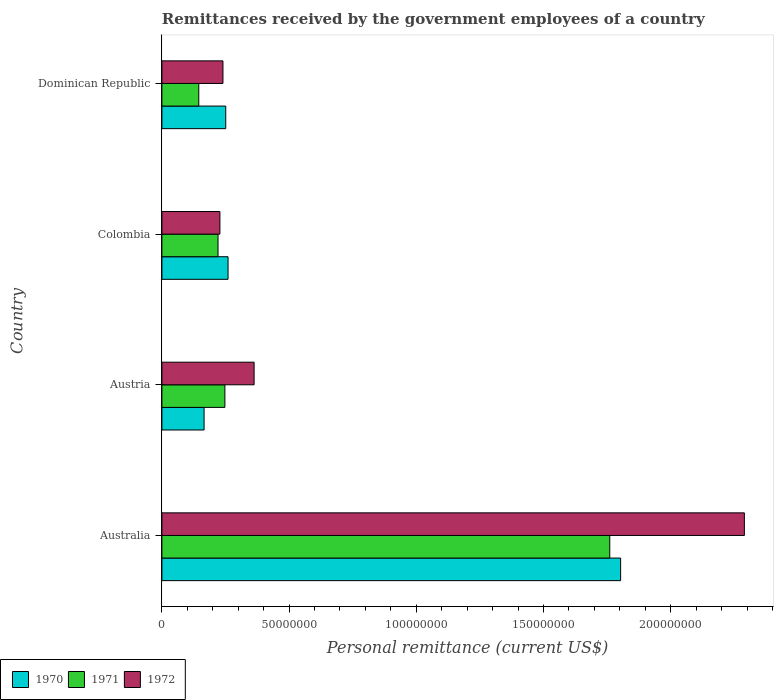How many different coloured bars are there?
Your answer should be compact. 3. How many bars are there on the 3rd tick from the top?
Offer a very short reply. 3. How many bars are there on the 4th tick from the bottom?
Ensure brevity in your answer.  3. What is the label of the 3rd group of bars from the top?
Your response must be concise. Austria. In how many cases, is the number of bars for a given country not equal to the number of legend labels?
Keep it short and to the point. 0. What is the remittances received by the government employees in 1972 in Colombia?
Keep it short and to the point. 2.28e+07. Across all countries, what is the maximum remittances received by the government employees in 1971?
Keep it short and to the point. 1.76e+08. Across all countries, what is the minimum remittances received by the government employees in 1970?
Keep it short and to the point. 1.66e+07. In which country was the remittances received by the government employees in 1971 maximum?
Your answer should be compact. Australia. What is the total remittances received by the government employees in 1972 in the graph?
Give a very brief answer. 3.12e+08. What is the difference between the remittances received by the government employees in 1971 in Colombia and that in Dominican Republic?
Keep it short and to the point. 7.57e+06. What is the difference between the remittances received by the government employees in 1970 in Austria and the remittances received by the government employees in 1971 in Australia?
Offer a terse response. -1.59e+08. What is the average remittances received by the government employees in 1972 per country?
Your response must be concise. 7.80e+07. What is the difference between the remittances received by the government employees in 1972 and remittances received by the government employees in 1970 in Austria?
Ensure brevity in your answer.  1.97e+07. What is the ratio of the remittances received by the government employees in 1972 in Austria to that in Dominican Republic?
Your answer should be compact. 1.51. Is the remittances received by the government employees in 1972 in Austria less than that in Dominican Republic?
Keep it short and to the point. No. Is the difference between the remittances received by the government employees in 1972 in Australia and Colombia greater than the difference between the remittances received by the government employees in 1970 in Australia and Colombia?
Keep it short and to the point. Yes. What is the difference between the highest and the second highest remittances received by the government employees in 1971?
Ensure brevity in your answer.  1.51e+08. What is the difference between the highest and the lowest remittances received by the government employees in 1970?
Give a very brief answer. 1.64e+08. What does the 3rd bar from the bottom in Austria represents?
Provide a succinct answer. 1972. How many bars are there?
Your answer should be very brief. 12. Are all the bars in the graph horizontal?
Your answer should be very brief. Yes. What is the difference between two consecutive major ticks on the X-axis?
Your response must be concise. 5.00e+07. Does the graph contain any zero values?
Give a very brief answer. No. Does the graph contain grids?
Your answer should be very brief. No. How are the legend labels stacked?
Make the answer very short. Horizontal. What is the title of the graph?
Make the answer very short. Remittances received by the government employees of a country. What is the label or title of the X-axis?
Provide a succinct answer. Personal remittance (current US$). What is the label or title of the Y-axis?
Give a very brief answer. Country. What is the Personal remittance (current US$) of 1970 in Australia?
Give a very brief answer. 1.80e+08. What is the Personal remittance (current US$) in 1971 in Australia?
Keep it short and to the point. 1.76e+08. What is the Personal remittance (current US$) in 1972 in Australia?
Provide a succinct answer. 2.29e+08. What is the Personal remittance (current US$) of 1970 in Austria?
Ensure brevity in your answer.  1.66e+07. What is the Personal remittance (current US$) of 1971 in Austria?
Give a very brief answer. 2.48e+07. What is the Personal remittance (current US$) in 1972 in Austria?
Ensure brevity in your answer.  3.62e+07. What is the Personal remittance (current US$) of 1970 in Colombia?
Make the answer very short. 2.60e+07. What is the Personal remittance (current US$) in 1971 in Colombia?
Provide a short and direct response. 2.21e+07. What is the Personal remittance (current US$) of 1972 in Colombia?
Your answer should be compact. 2.28e+07. What is the Personal remittance (current US$) of 1970 in Dominican Republic?
Ensure brevity in your answer.  2.51e+07. What is the Personal remittance (current US$) in 1971 in Dominican Republic?
Offer a terse response. 1.45e+07. What is the Personal remittance (current US$) of 1972 in Dominican Republic?
Keep it short and to the point. 2.40e+07. Across all countries, what is the maximum Personal remittance (current US$) in 1970?
Provide a succinct answer. 1.80e+08. Across all countries, what is the maximum Personal remittance (current US$) in 1971?
Keep it short and to the point. 1.76e+08. Across all countries, what is the maximum Personal remittance (current US$) of 1972?
Offer a terse response. 2.29e+08. Across all countries, what is the minimum Personal remittance (current US$) of 1970?
Make the answer very short. 1.66e+07. Across all countries, what is the minimum Personal remittance (current US$) of 1971?
Provide a short and direct response. 1.45e+07. Across all countries, what is the minimum Personal remittance (current US$) of 1972?
Offer a very short reply. 2.28e+07. What is the total Personal remittance (current US$) of 1970 in the graph?
Your response must be concise. 2.48e+08. What is the total Personal remittance (current US$) in 1971 in the graph?
Your response must be concise. 2.37e+08. What is the total Personal remittance (current US$) in 1972 in the graph?
Your answer should be very brief. 3.12e+08. What is the difference between the Personal remittance (current US$) of 1970 in Australia and that in Austria?
Give a very brief answer. 1.64e+08. What is the difference between the Personal remittance (current US$) in 1971 in Australia and that in Austria?
Your response must be concise. 1.51e+08. What is the difference between the Personal remittance (current US$) in 1972 in Australia and that in Austria?
Offer a very short reply. 1.93e+08. What is the difference between the Personal remittance (current US$) in 1970 in Australia and that in Colombia?
Your answer should be very brief. 1.54e+08. What is the difference between the Personal remittance (current US$) of 1971 in Australia and that in Colombia?
Make the answer very short. 1.54e+08. What is the difference between the Personal remittance (current US$) in 1972 in Australia and that in Colombia?
Offer a terse response. 2.06e+08. What is the difference between the Personal remittance (current US$) of 1970 in Australia and that in Dominican Republic?
Offer a very short reply. 1.55e+08. What is the difference between the Personal remittance (current US$) in 1971 in Australia and that in Dominican Republic?
Your answer should be compact. 1.62e+08. What is the difference between the Personal remittance (current US$) in 1972 in Australia and that in Dominican Republic?
Provide a short and direct response. 2.05e+08. What is the difference between the Personal remittance (current US$) in 1970 in Austria and that in Colombia?
Make the answer very short. -9.42e+06. What is the difference between the Personal remittance (current US$) of 1971 in Austria and that in Colombia?
Your answer should be compact. 2.69e+06. What is the difference between the Personal remittance (current US$) in 1972 in Austria and that in Colombia?
Offer a terse response. 1.34e+07. What is the difference between the Personal remittance (current US$) in 1970 in Austria and that in Dominican Republic?
Your answer should be very brief. -8.52e+06. What is the difference between the Personal remittance (current US$) in 1971 in Austria and that in Dominican Republic?
Provide a succinct answer. 1.03e+07. What is the difference between the Personal remittance (current US$) in 1972 in Austria and that in Dominican Republic?
Give a very brief answer. 1.22e+07. What is the difference between the Personal remittance (current US$) of 1970 in Colombia and that in Dominican Republic?
Keep it short and to the point. 9.00e+05. What is the difference between the Personal remittance (current US$) of 1971 in Colombia and that in Dominican Republic?
Provide a short and direct response. 7.57e+06. What is the difference between the Personal remittance (current US$) in 1972 in Colombia and that in Dominican Republic?
Provide a succinct answer. -1.20e+06. What is the difference between the Personal remittance (current US$) of 1970 in Australia and the Personal remittance (current US$) of 1971 in Austria?
Give a very brief answer. 1.56e+08. What is the difference between the Personal remittance (current US$) of 1970 in Australia and the Personal remittance (current US$) of 1972 in Austria?
Your response must be concise. 1.44e+08. What is the difference between the Personal remittance (current US$) in 1971 in Australia and the Personal remittance (current US$) in 1972 in Austria?
Provide a succinct answer. 1.40e+08. What is the difference between the Personal remittance (current US$) of 1970 in Australia and the Personal remittance (current US$) of 1971 in Colombia?
Your response must be concise. 1.58e+08. What is the difference between the Personal remittance (current US$) of 1970 in Australia and the Personal remittance (current US$) of 1972 in Colombia?
Make the answer very short. 1.58e+08. What is the difference between the Personal remittance (current US$) in 1971 in Australia and the Personal remittance (current US$) in 1972 in Colombia?
Give a very brief answer. 1.53e+08. What is the difference between the Personal remittance (current US$) in 1970 in Australia and the Personal remittance (current US$) in 1971 in Dominican Republic?
Make the answer very short. 1.66e+08. What is the difference between the Personal remittance (current US$) in 1970 in Australia and the Personal remittance (current US$) in 1972 in Dominican Republic?
Your response must be concise. 1.56e+08. What is the difference between the Personal remittance (current US$) in 1971 in Australia and the Personal remittance (current US$) in 1972 in Dominican Republic?
Provide a short and direct response. 1.52e+08. What is the difference between the Personal remittance (current US$) of 1970 in Austria and the Personal remittance (current US$) of 1971 in Colombia?
Your response must be concise. -5.49e+06. What is the difference between the Personal remittance (current US$) in 1970 in Austria and the Personal remittance (current US$) in 1972 in Colombia?
Make the answer very short. -6.22e+06. What is the difference between the Personal remittance (current US$) in 1971 in Austria and the Personal remittance (current US$) in 1972 in Colombia?
Your response must be concise. 1.96e+06. What is the difference between the Personal remittance (current US$) in 1970 in Austria and the Personal remittance (current US$) in 1971 in Dominican Republic?
Offer a terse response. 2.08e+06. What is the difference between the Personal remittance (current US$) in 1970 in Austria and the Personal remittance (current US$) in 1972 in Dominican Republic?
Provide a short and direct response. -7.42e+06. What is the difference between the Personal remittance (current US$) in 1971 in Austria and the Personal remittance (current US$) in 1972 in Dominican Republic?
Give a very brief answer. 7.60e+05. What is the difference between the Personal remittance (current US$) in 1970 in Colombia and the Personal remittance (current US$) in 1971 in Dominican Republic?
Give a very brief answer. 1.15e+07. What is the difference between the Personal remittance (current US$) of 1971 in Colombia and the Personal remittance (current US$) of 1972 in Dominican Republic?
Keep it short and to the point. -1.93e+06. What is the average Personal remittance (current US$) in 1970 per country?
Make the answer very short. 6.20e+07. What is the average Personal remittance (current US$) in 1971 per country?
Provide a succinct answer. 5.93e+07. What is the average Personal remittance (current US$) of 1972 per country?
Offer a terse response. 7.80e+07. What is the difference between the Personal remittance (current US$) in 1970 and Personal remittance (current US$) in 1971 in Australia?
Provide a short and direct response. 4.27e+06. What is the difference between the Personal remittance (current US$) of 1970 and Personal remittance (current US$) of 1972 in Australia?
Offer a very short reply. -4.86e+07. What is the difference between the Personal remittance (current US$) in 1971 and Personal remittance (current US$) in 1972 in Australia?
Your answer should be very brief. -5.29e+07. What is the difference between the Personal remittance (current US$) in 1970 and Personal remittance (current US$) in 1971 in Austria?
Ensure brevity in your answer.  -8.18e+06. What is the difference between the Personal remittance (current US$) of 1970 and Personal remittance (current US$) of 1972 in Austria?
Keep it short and to the point. -1.97e+07. What is the difference between the Personal remittance (current US$) in 1971 and Personal remittance (current US$) in 1972 in Austria?
Offer a very short reply. -1.15e+07. What is the difference between the Personal remittance (current US$) in 1970 and Personal remittance (current US$) in 1971 in Colombia?
Keep it short and to the point. 3.93e+06. What is the difference between the Personal remittance (current US$) in 1970 and Personal remittance (current US$) in 1972 in Colombia?
Make the answer very short. 3.20e+06. What is the difference between the Personal remittance (current US$) of 1971 and Personal remittance (current US$) of 1972 in Colombia?
Provide a succinct answer. -7.34e+05. What is the difference between the Personal remittance (current US$) in 1970 and Personal remittance (current US$) in 1971 in Dominican Republic?
Provide a succinct answer. 1.06e+07. What is the difference between the Personal remittance (current US$) in 1970 and Personal remittance (current US$) in 1972 in Dominican Republic?
Your answer should be compact. 1.10e+06. What is the difference between the Personal remittance (current US$) in 1971 and Personal remittance (current US$) in 1972 in Dominican Republic?
Your answer should be very brief. -9.50e+06. What is the ratio of the Personal remittance (current US$) in 1970 in Australia to that in Austria?
Your answer should be compact. 10.88. What is the ratio of the Personal remittance (current US$) of 1971 in Australia to that in Austria?
Your answer should be very brief. 7.11. What is the ratio of the Personal remittance (current US$) in 1972 in Australia to that in Austria?
Ensure brevity in your answer.  6.32. What is the ratio of the Personal remittance (current US$) in 1970 in Australia to that in Colombia?
Your answer should be compact. 6.94. What is the ratio of the Personal remittance (current US$) in 1971 in Australia to that in Colombia?
Provide a short and direct response. 7.98. What is the ratio of the Personal remittance (current US$) in 1972 in Australia to that in Colombia?
Provide a short and direct response. 10.04. What is the ratio of the Personal remittance (current US$) in 1970 in Australia to that in Dominican Republic?
Offer a very short reply. 7.18. What is the ratio of the Personal remittance (current US$) of 1971 in Australia to that in Dominican Republic?
Provide a succinct answer. 12.14. What is the ratio of the Personal remittance (current US$) of 1972 in Australia to that in Dominican Republic?
Provide a succinct answer. 9.54. What is the ratio of the Personal remittance (current US$) of 1970 in Austria to that in Colombia?
Your answer should be compact. 0.64. What is the ratio of the Personal remittance (current US$) of 1971 in Austria to that in Colombia?
Offer a terse response. 1.12. What is the ratio of the Personal remittance (current US$) of 1972 in Austria to that in Colombia?
Ensure brevity in your answer.  1.59. What is the ratio of the Personal remittance (current US$) of 1970 in Austria to that in Dominican Republic?
Keep it short and to the point. 0.66. What is the ratio of the Personal remittance (current US$) of 1971 in Austria to that in Dominican Republic?
Offer a terse response. 1.71. What is the ratio of the Personal remittance (current US$) in 1972 in Austria to that in Dominican Republic?
Your answer should be compact. 1.51. What is the ratio of the Personal remittance (current US$) in 1970 in Colombia to that in Dominican Republic?
Offer a terse response. 1.04. What is the ratio of the Personal remittance (current US$) in 1971 in Colombia to that in Dominican Republic?
Ensure brevity in your answer.  1.52. What is the difference between the highest and the second highest Personal remittance (current US$) in 1970?
Ensure brevity in your answer.  1.54e+08. What is the difference between the highest and the second highest Personal remittance (current US$) in 1971?
Give a very brief answer. 1.51e+08. What is the difference between the highest and the second highest Personal remittance (current US$) in 1972?
Ensure brevity in your answer.  1.93e+08. What is the difference between the highest and the lowest Personal remittance (current US$) in 1970?
Offer a very short reply. 1.64e+08. What is the difference between the highest and the lowest Personal remittance (current US$) in 1971?
Provide a succinct answer. 1.62e+08. What is the difference between the highest and the lowest Personal remittance (current US$) of 1972?
Provide a succinct answer. 2.06e+08. 